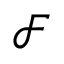Convert formula to latex. <formula><loc_0><loc_0><loc_500><loc_500>{ \mathcal { F } }</formula> 